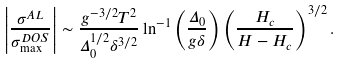<formula> <loc_0><loc_0><loc_500><loc_500>\left | \frac { \sigma ^ { A L } } { \sigma ^ { D O S } _ { \max } } \right | \sim \frac { g ^ { - 3 / 2 } T ^ { 2 } } { \Delta _ { 0 } ^ { 1 / 2 } \delta ^ { 3 / 2 } } \ln ^ { - 1 } \left ( \frac { \Delta _ { 0 } } { g \delta } \right ) \left ( \frac { H _ { c } } { H - H _ { c } } \right ) ^ { 3 / 2 } .</formula> 